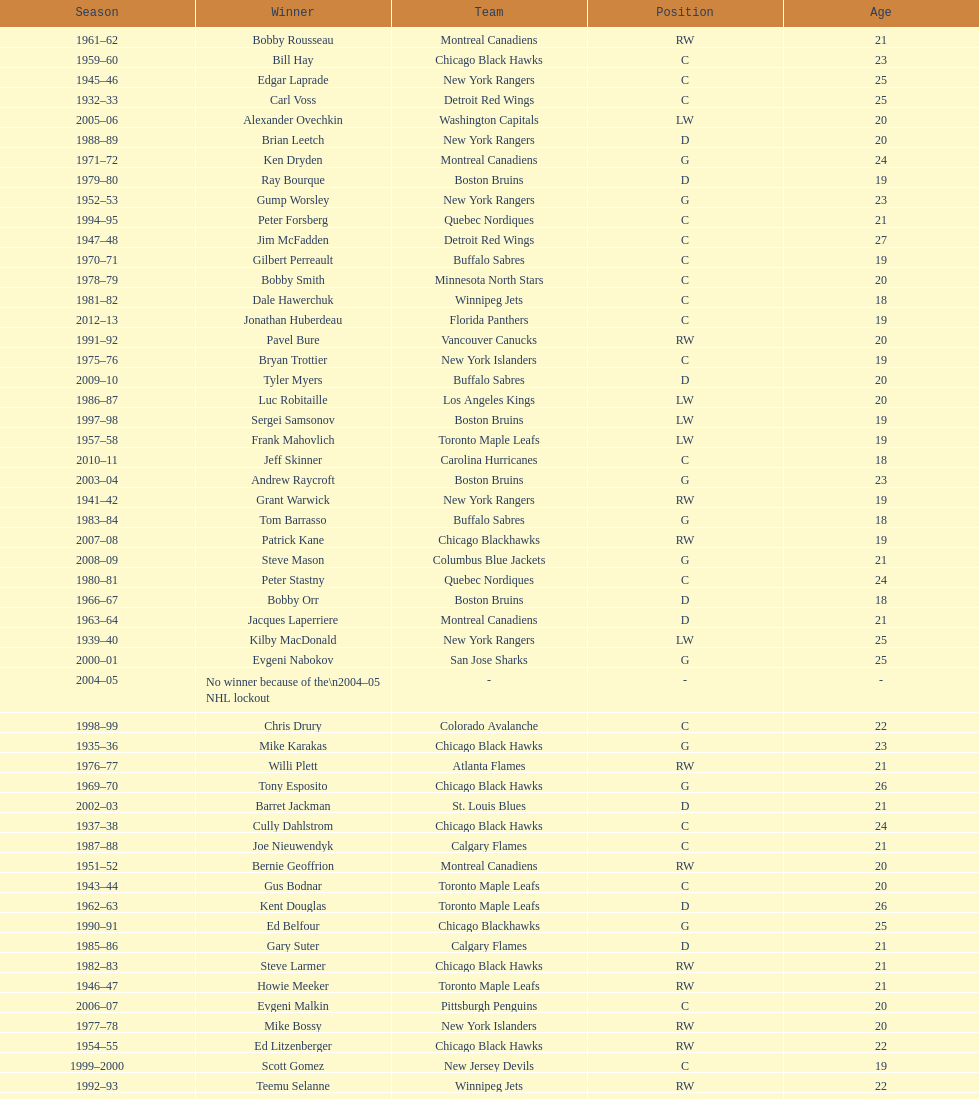Who was the first calder memorial trophy winner from the boston bruins? Frank Brimsek. 